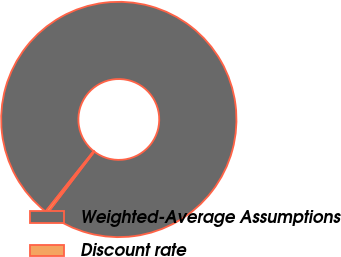Convert chart. <chart><loc_0><loc_0><loc_500><loc_500><pie_chart><fcel>Weighted-Average Assumptions<fcel>Discount rate<nl><fcel>99.66%<fcel>0.34%<nl></chart> 